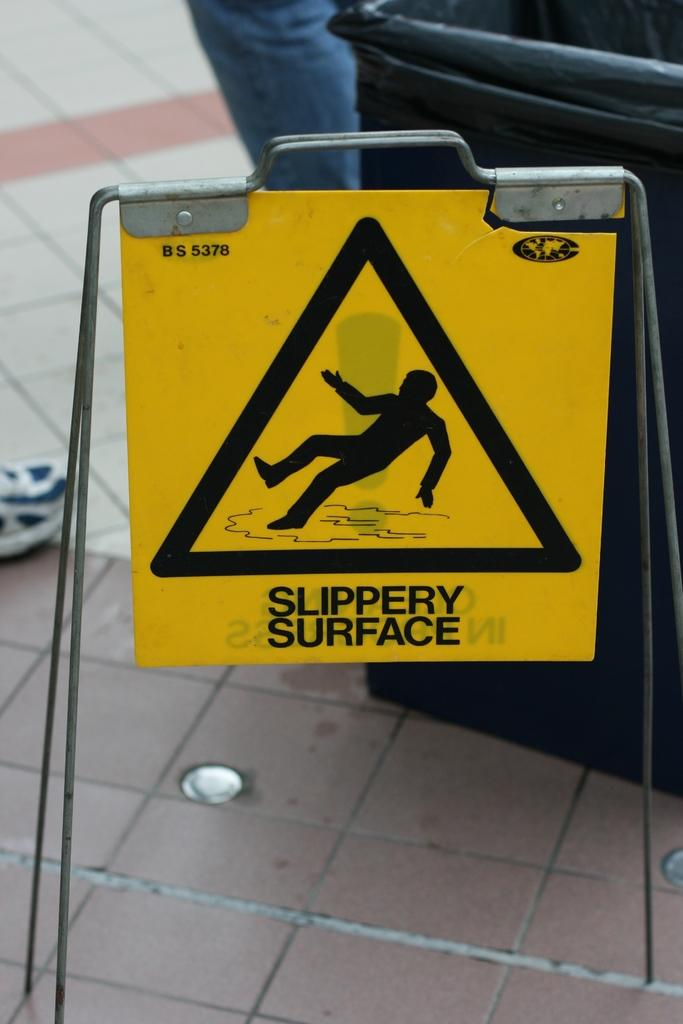<image>
Summarize the visual content of the image. A yellow placard hanging over a tiled floor states, "Slippery Surface." 